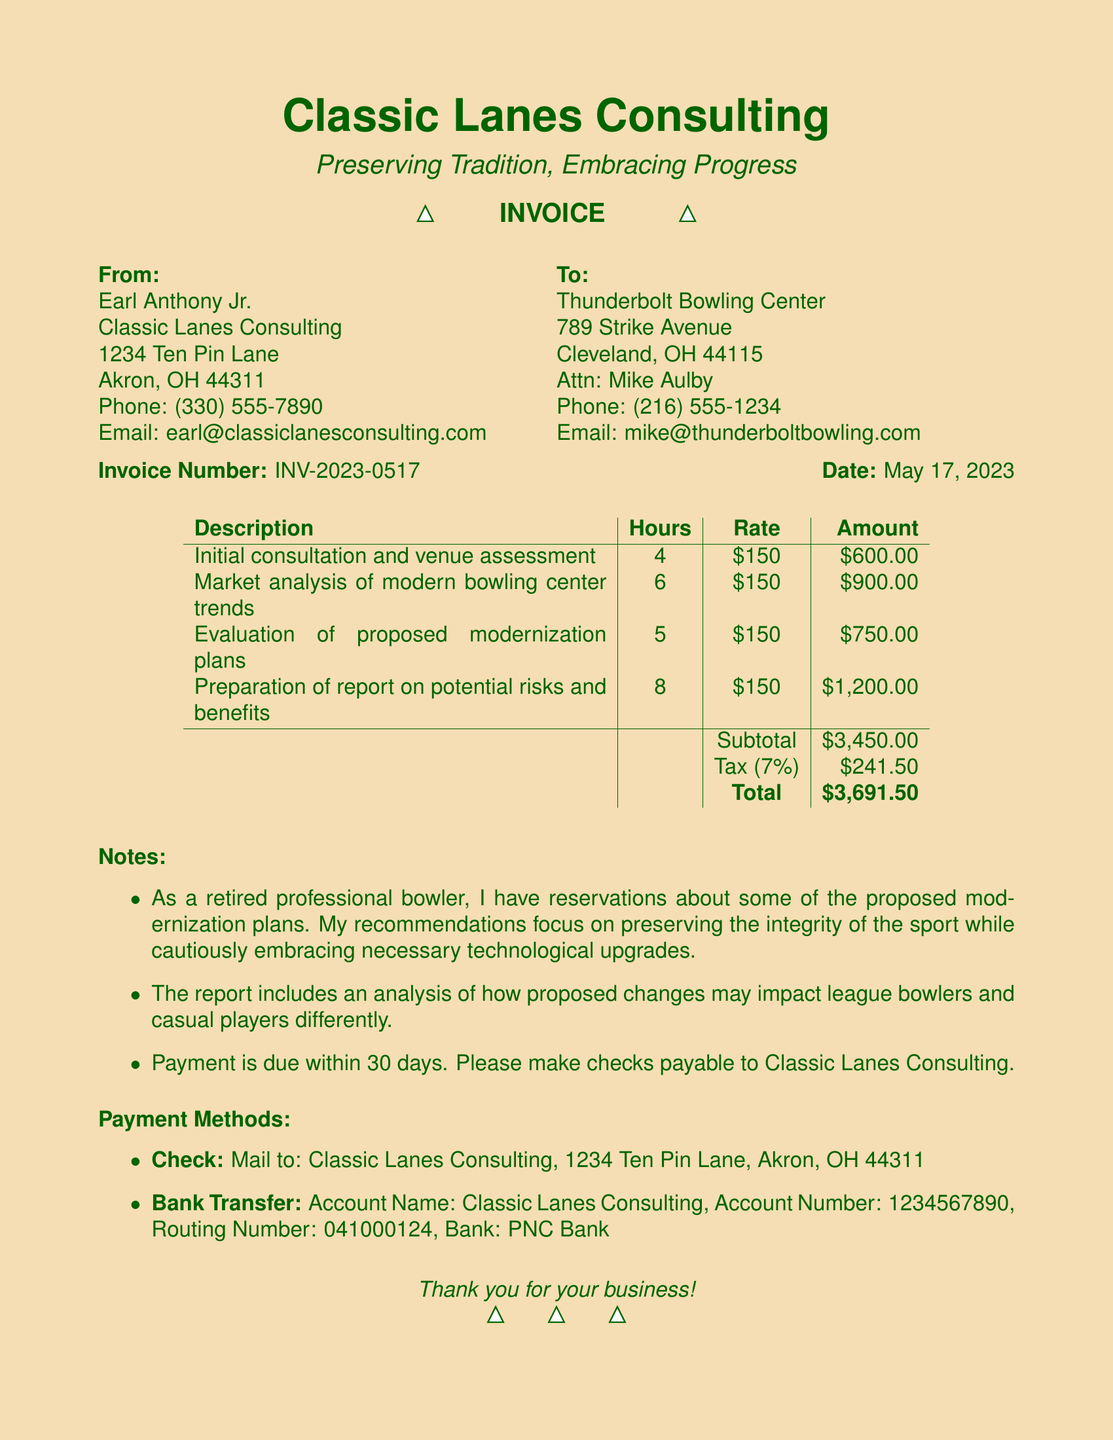What is the invoice number? The invoice number is specifically provided in the document for identification purposes.
Answer: INV-2023-0517 What is the total amount due? The total amount due is calculated at the end of the document, summing up the subtotal and tax.
Answer: $3,691.50 Who is the consultant? The consultant's name is mentioned in the document, detailing their role in the service provided.
Answer: Earl Anthony Jr How many hours were dedicated to the market analysis? The number of hours allocated for each service is specified within the services section of the document.
Answer: 6 What is the tax rate applied in the invoice? The tax rate is indicated in the invoice for calculating the total amount owed.
Answer: 7% What is the main focus of the consultant's recommendations? This question assesses understanding of the consultant's perspective and priorities regarding modernization.
Answer: Preserving the integrity of the sport How many services are listed in the invoice? The document outlines specific services rendered, which can be counted.
Answer: 4 What payment methods are accepted? The document specifies different payment methods available for settling the invoice, indicating flexibility.
Answer: Check, Bank Transfer What is the due date for payment? The document includes a note regarding payment deadlines to inform the client when payment is expected.
Answer: Within 30 days 